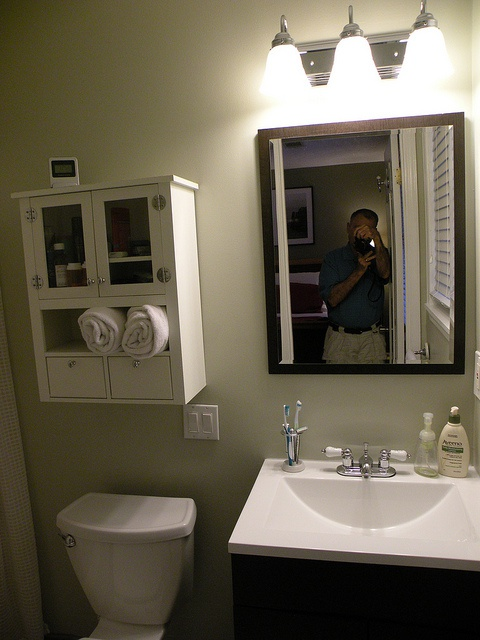Describe the objects in this image and their specific colors. I can see sink in black, lightgray, and darkgray tones, toilet in black, darkgreen, and gray tones, people in black, darkgreen, and gray tones, bottle in black, tan, and gray tones, and bottle in black, gray, and darkgray tones in this image. 